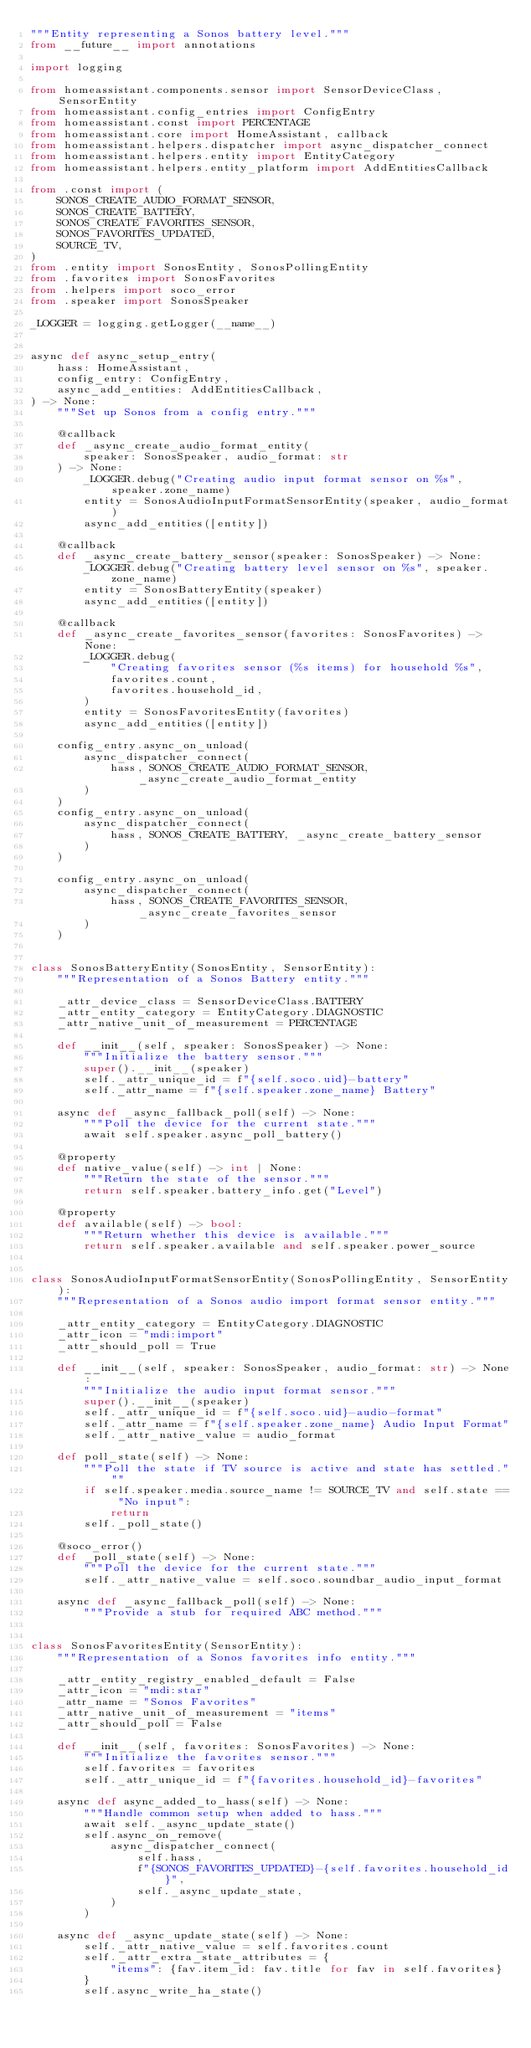Convert code to text. <code><loc_0><loc_0><loc_500><loc_500><_Python_>"""Entity representing a Sonos battery level."""
from __future__ import annotations

import logging

from homeassistant.components.sensor import SensorDeviceClass, SensorEntity
from homeassistant.config_entries import ConfigEntry
from homeassistant.const import PERCENTAGE
from homeassistant.core import HomeAssistant, callback
from homeassistant.helpers.dispatcher import async_dispatcher_connect
from homeassistant.helpers.entity import EntityCategory
from homeassistant.helpers.entity_platform import AddEntitiesCallback

from .const import (
    SONOS_CREATE_AUDIO_FORMAT_SENSOR,
    SONOS_CREATE_BATTERY,
    SONOS_CREATE_FAVORITES_SENSOR,
    SONOS_FAVORITES_UPDATED,
    SOURCE_TV,
)
from .entity import SonosEntity, SonosPollingEntity
from .favorites import SonosFavorites
from .helpers import soco_error
from .speaker import SonosSpeaker

_LOGGER = logging.getLogger(__name__)


async def async_setup_entry(
    hass: HomeAssistant,
    config_entry: ConfigEntry,
    async_add_entities: AddEntitiesCallback,
) -> None:
    """Set up Sonos from a config entry."""

    @callback
    def _async_create_audio_format_entity(
        speaker: SonosSpeaker, audio_format: str
    ) -> None:
        _LOGGER.debug("Creating audio input format sensor on %s", speaker.zone_name)
        entity = SonosAudioInputFormatSensorEntity(speaker, audio_format)
        async_add_entities([entity])

    @callback
    def _async_create_battery_sensor(speaker: SonosSpeaker) -> None:
        _LOGGER.debug("Creating battery level sensor on %s", speaker.zone_name)
        entity = SonosBatteryEntity(speaker)
        async_add_entities([entity])

    @callback
    def _async_create_favorites_sensor(favorites: SonosFavorites) -> None:
        _LOGGER.debug(
            "Creating favorites sensor (%s items) for household %s",
            favorites.count,
            favorites.household_id,
        )
        entity = SonosFavoritesEntity(favorites)
        async_add_entities([entity])

    config_entry.async_on_unload(
        async_dispatcher_connect(
            hass, SONOS_CREATE_AUDIO_FORMAT_SENSOR, _async_create_audio_format_entity
        )
    )
    config_entry.async_on_unload(
        async_dispatcher_connect(
            hass, SONOS_CREATE_BATTERY, _async_create_battery_sensor
        )
    )

    config_entry.async_on_unload(
        async_dispatcher_connect(
            hass, SONOS_CREATE_FAVORITES_SENSOR, _async_create_favorites_sensor
        )
    )


class SonosBatteryEntity(SonosEntity, SensorEntity):
    """Representation of a Sonos Battery entity."""

    _attr_device_class = SensorDeviceClass.BATTERY
    _attr_entity_category = EntityCategory.DIAGNOSTIC
    _attr_native_unit_of_measurement = PERCENTAGE

    def __init__(self, speaker: SonosSpeaker) -> None:
        """Initialize the battery sensor."""
        super().__init__(speaker)
        self._attr_unique_id = f"{self.soco.uid}-battery"
        self._attr_name = f"{self.speaker.zone_name} Battery"

    async def _async_fallback_poll(self) -> None:
        """Poll the device for the current state."""
        await self.speaker.async_poll_battery()

    @property
    def native_value(self) -> int | None:
        """Return the state of the sensor."""
        return self.speaker.battery_info.get("Level")

    @property
    def available(self) -> bool:
        """Return whether this device is available."""
        return self.speaker.available and self.speaker.power_source


class SonosAudioInputFormatSensorEntity(SonosPollingEntity, SensorEntity):
    """Representation of a Sonos audio import format sensor entity."""

    _attr_entity_category = EntityCategory.DIAGNOSTIC
    _attr_icon = "mdi:import"
    _attr_should_poll = True

    def __init__(self, speaker: SonosSpeaker, audio_format: str) -> None:
        """Initialize the audio input format sensor."""
        super().__init__(speaker)
        self._attr_unique_id = f"{self.soco.uid}-audio-format"
        self._attr_name = f"{self.speaker.zone_name} Audio Input Format"
        self._attr_native_value = audio_format

    def poll_state(self) -> None:
        """Poll the state if TV source is active and state has settled."""
        if self.speaker.media.source_name != SOURCE_TV and self.state == "No input":
            return
        self._poll_state()

    @soco_error()
    def _poll_state(self) -> None:
        """Poll the device for the current state."""
        self._attr_native_value = self.soco.soundbar_audio_input_format

    async def _async_fallback_poll(self) -> None:
        """Provide a stub for required ABC method."""


class SonosFavoritesEntity(SensorEntity):
    """Representation of a Sonos favorites info entity."""

    _attr_entity_registry_enabled_default = False
    _attr_icon = "mdi:star"
    _attr_name = "Sonos Favorites"
    _attr_native_unit_of_measurement = "items"
    _attr_should_poll = False

    def __init__(self, favorites: SonosFavorites) -> None:
        """Initialize the favorites sensor."""
        self.favorites = favorites
        self._attr_unique_id = f"{favorites.household_id}-favorites"

    async def async_added_to_hass(self) -> None:
        """Handle common setup when added to hass."""
        await self._async_update_state()
        self.async_on_remove(
            async_dispatcher_connect(
                self.hass,
                f"{SONOS_FAVORITES_UPDATED}-{self.favorites.household_id}",
                self._async_update_state,
            )
        )

    async def _async_update_state(self) -> None:
        self._attr_native_value = self.favorites.count
        self._attr_extra_state_attributes = {
            "items": {fav.item_id: fav.title for fav in self.favorites}
        }
        self.async_write_ha_state()
</code> 